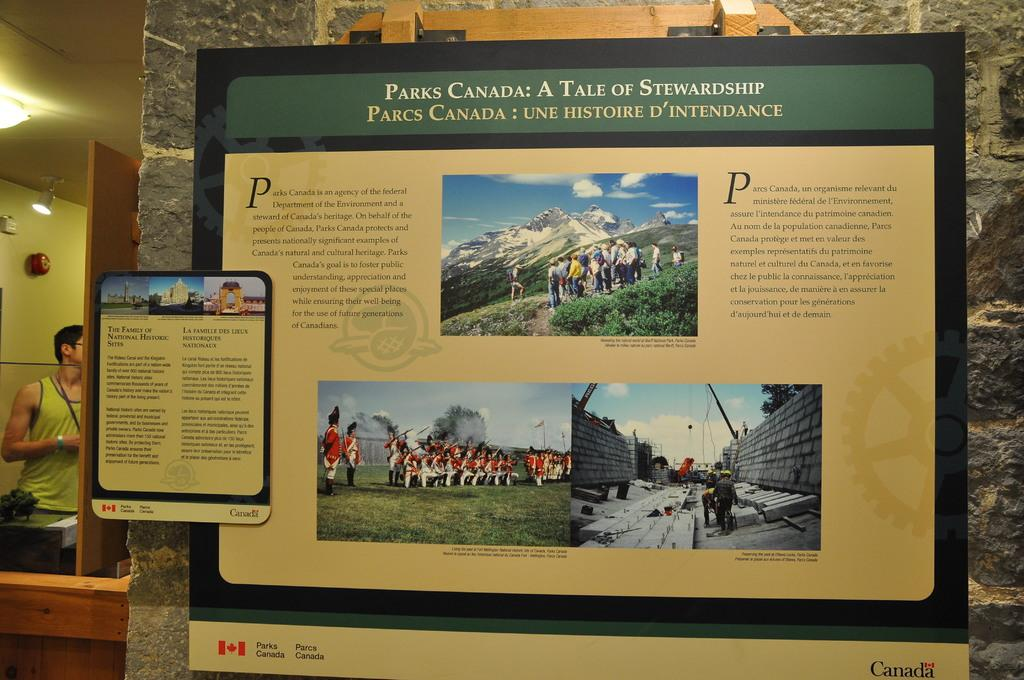Provide a one-sentence caption for the provided image. A sign that tells about the founding of parks in Canada. 